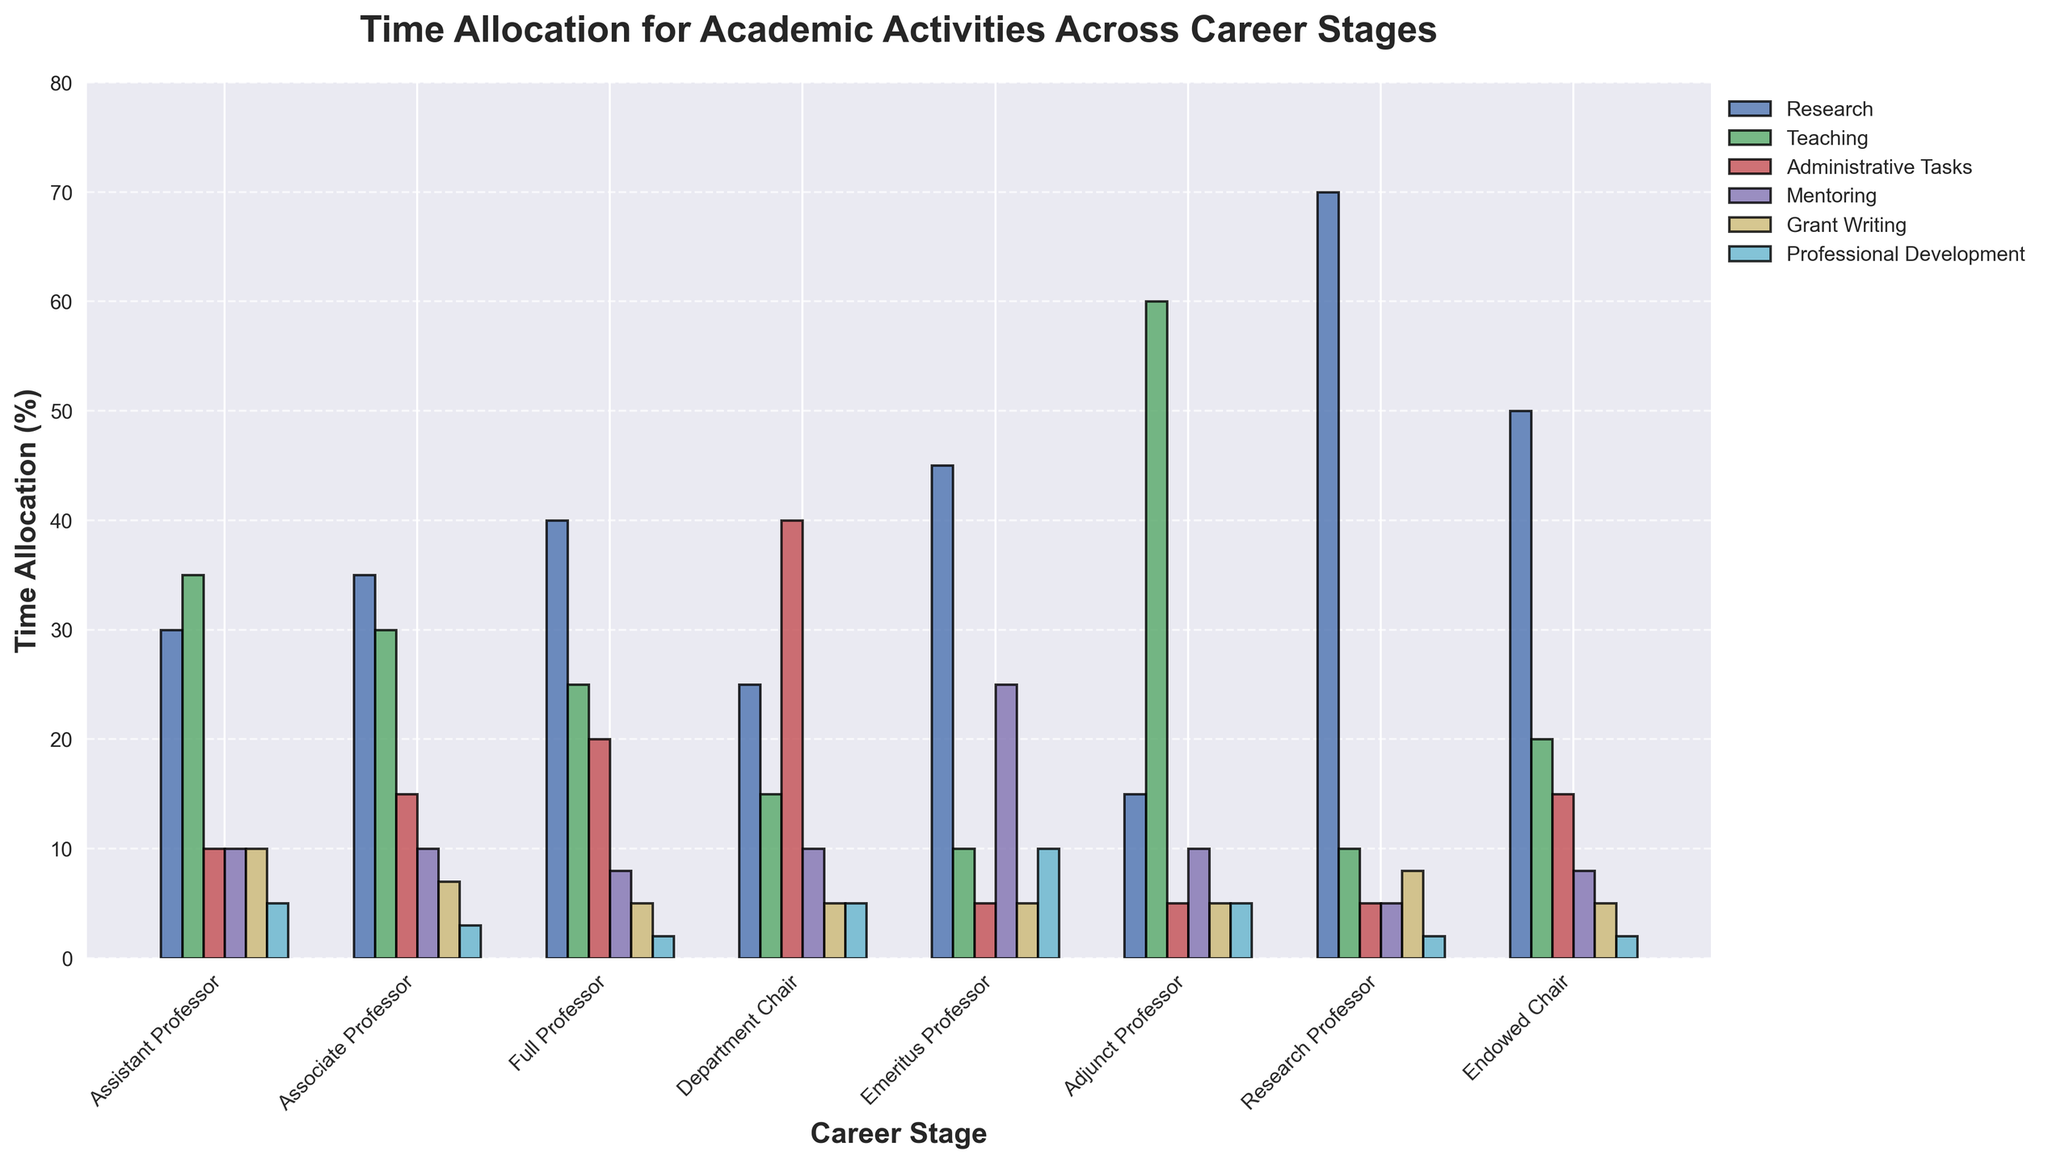What career stage allocates the most time to teaching? By looking at the height of the bars and the labels, the Adjunct Professor category has the tallest bar for teaching. This indicates that Adjunct Professors allocate more time to teaching compared to other career stages.
Answer: Adjunct Professor Which career stage allocates the least amount of time to administrative tasks? The figure shows that both Adjunct Professors and Emeritus Professors have the shortest bars for administrative tasks, each at 5%. This indicates they allocate the least amount of time to administrative tasks.
Answer: Adjunct Professor, Emeritus Professor Which academic activity is given the highest allocation of time by Research Professors? By examining the height of the bars corresponding to Research Professors, the tallest bar is for research, indicating that Research Professors allocate the majority of their time to research.
Answer: Research What is the combined percentage of time allocated to mentoring and professional development by an Emeritus Professor? The figure shows that Emeritus Professors allocate 25% of their time to mentoring and 10% to professional development. Adding these together gives 25% + 10% = 35%.
Answer: 35% Compare the time allocation for administrative tasks between Assistant Professors and Department Chairs. What is the difference? The height of the bars shows that Assistant Professors allocate 10% of their time to administrative tasks, whereas Department Chairs allocate 40%. The difference is calculated by 40% - 10% = 30%.
Answer: 30% Which career stage allocates more time to grant writing: Research Professors or Associate Professors? By comparing the heights of the bars for grant writing, Research Professors allocate 8%, while Associate Professors allocate 7%. Therefore, Research Professors allocate more time.
Answer: Research Professors How much more time do Full Professors allocate to research compared to Emeritus Professors? Full Professors allocate 40% of their time to research, while Emeritus Professors allocate 45%. The difference is 45% - 40% = 5%, which means Emeritus Professors actually allocate 5% more time than Full Professors.
Answer: 5% more (Emeritus Professors) What is the average percentage of time allocated to teaching by Full Professors, Associate Professors, and Assistant Professors? The time allocations for teaching by each are 25% (Full Professors), 30% (Associate Professors), and 35% (Assistant Professors). The average is calculated as (25% + 30% + 35%) / 3 = 30%.
Answer: 30% If you combine the time spent on research and teaching for Endowed Chairs, what percentage of their total time does this represent? The figure shows that Endowed Chairs allocate 50% of their time to research and 20% to teaching. Combined, this is 50% + 20% = 70%.
Answer: 70% Which career stage has the most diverse allocation of time across all six activities, and what is the range of percentages? The Department Chair shows the widest range of time allocation percentages, from 5% for grant writing and professional development to 40% for administrative tasks. The range is calculated as 40% - 5% = 35%.
Answer: Department Chair, 35% 